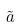<formula> <loc_0><loc_0><loc_500><loc_500>\tilde { a }</formula> 